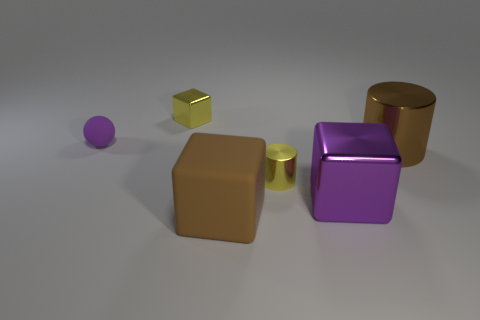Subtract all brown rubber blocks. How many blocks are left? 2 Add 3 big blue cubes. How many objects exist? 9 Subtract all yellow cylinders. How many cylinders are left? 1 Subtract 1 blocks. How many blocks are left? 2 Subtract all cylinders. How many objects are left? 4 Subtract 0 blue cubes. How many objects are left? 6 Subtract all yellow cylinders. Subtract all brown balls. How many cylinders are left? 1 Subtract all big red cylinders. Subtract all tiny cylinders. How many objects are left? 5 Add 5 large shiny things. How many large shiny things are left? 7 Add 4 large purple spheres. How many large purple spheres exist? 4 